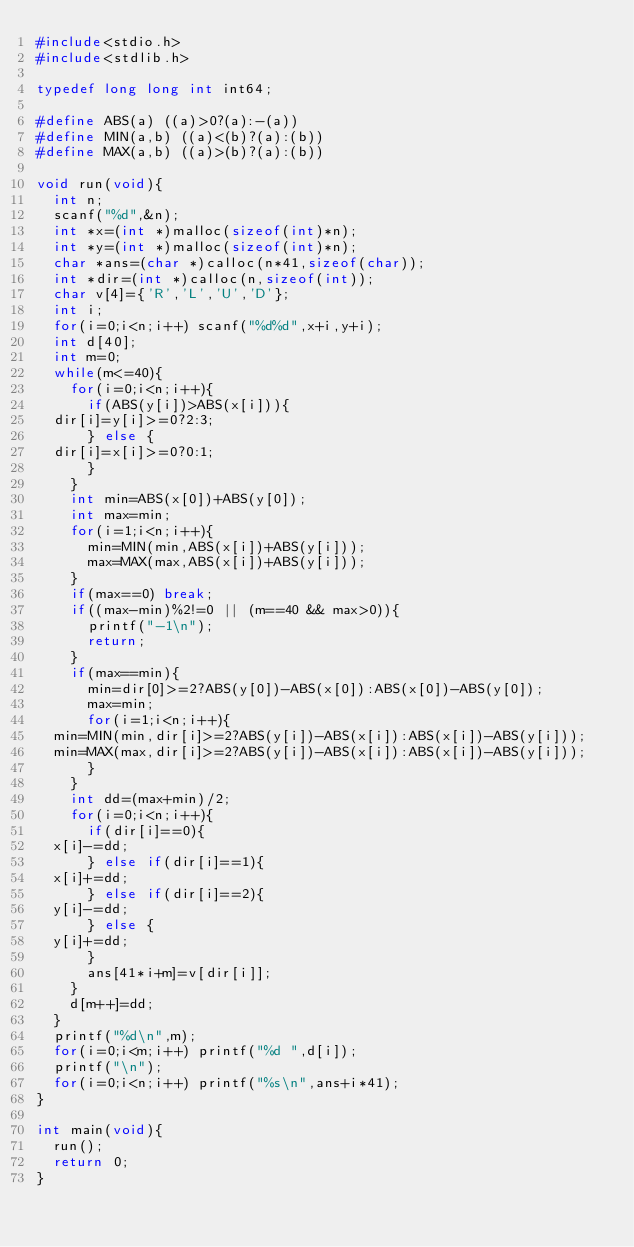Convert code to text. <code><loc_0><loc_0><loc_500><loc_500><_C_>#include<stdio.h>
#include<stdlib.h>

typedef long long int int64;

#define ABS(a) ((a)>0?(a):-(a))
#define MIN(a,b) ((a)<(b)?(a):(b))
#define MAX(a,b) ((a)>(b)?(a):(b))

void run(void){
  int n;
  scanf("%d",&n);
  int *x=(int *)malloc(sizeof(int)*n);
  int *y=(int *)malloc(sizeof(int)*n);
  char *ans=(char *)calloc(n*41,sizeof(char));
  int *dir=(int *)calloc(n,sizeof(int));
  char v[4]={'R','L','U','D'};
  int i;
  for(i=0;i<n;i++) scanf("%d%d",x+i,y+i);
  int d[40];
  int m=0;
  while(m<=40){
    for(i=0;i<n;i++){
      if(ABS(y[i])>ABS(x[i])){
	dir[i]=y[i]>=0?2:3;
      } else {
	dir[i]=x[i]>=0?0:1;
      }
    }
    int min=ABS(x[0])+ABS(y[0]);
    int max=min;
    for(i=1;i<n;i++){
      min=MIN(min,ABS(x[i])+ABS(y[i]));
      max=MAX(max,ABS(x[i])+ABS(y[i]));
    }
    if(max==0) break;
    if((max-min)%2!=0 || (m==40 && max>0)){
      printf("-1\n");
      return;
    }
    if(max==min){
      min=dir[0]>=2?ABS(y[0])-ABS(x[0]):ABS(x[0])-ABS(y[0]);
      max=min;
      for(i=1;i<n;i++){
	min=MIN(min,dir[i]>=2?ABS(y[i])-ABS(x[i]):ABS(x[i])-ABS(y[i]));
	min=MAX(max,dir[i]>=2?ABS(y[i])-ABS(x[i]):ABS(x[i])-ABS(y[i]));
      }
    }
    int dd=(max+min)/2;
    for(i=0;i<n;i++){
      if(dir[i]==0){
	x[i]-=dd;
      } else if(dir[i]==1){
	x[i]+=dd;
      } else if(dir[i]==2){
	y[i]-=dd;
      } else {
	y[i]+=dd;
      }
      ans[41*i+m]=v[dir[i]];
    }
    d[m++]=dd;
  }
  printf("%d\n",m);
  for(i=0;i<m;i++) printf("%d ",d[i]);
  printf("\n");
  for(i=0;i<n;i++) printf("%s\n",ans+i*41);
}

int main(void){
  run();
  return 0;
}
</code> 